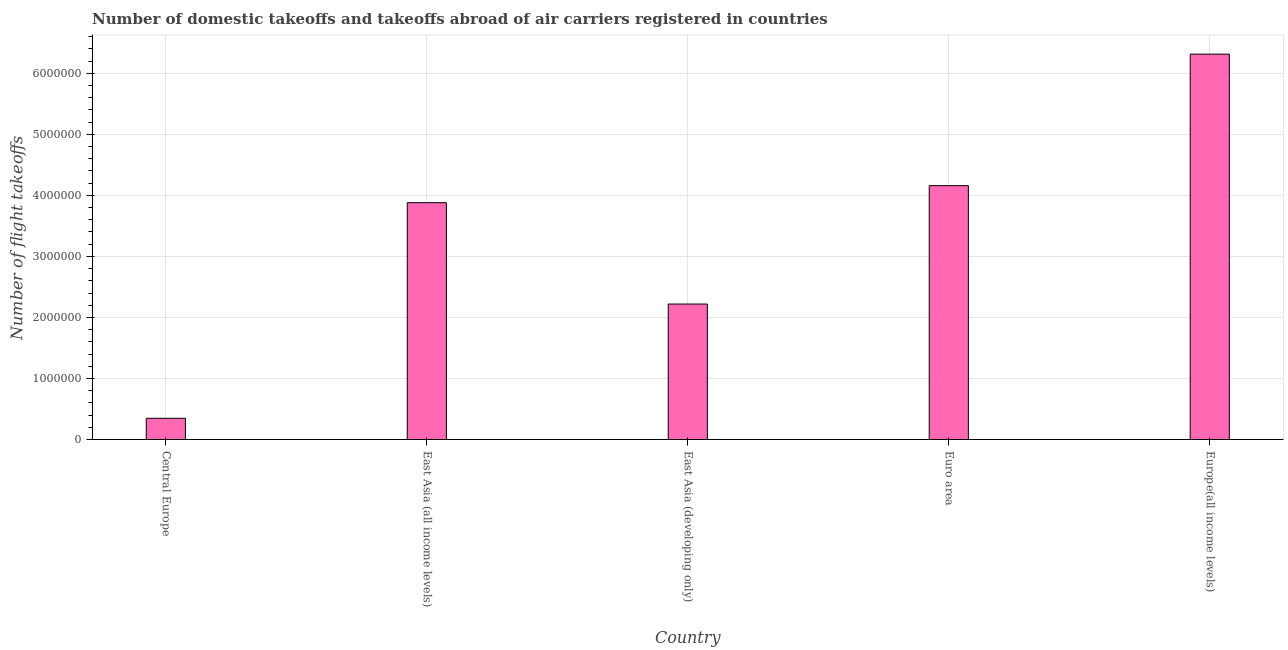Does the graph contain grids?
Provide a succinct answer. Yes. What is the title of the graph?
Keep it short and to the point. Number of domestic takeoffs and takeoffs abroad of air carriers registered in countries. What is the label or title of the X-axis?
Provide a short and direct response. Country. What is the label or title of the Y-axis?
Your answer should be compact. Number of flight takeoffs. What is the number of flight takeoffs in Euro area?
Provide a short and direct response. 4.16e+06. Across all countries, what is the maximum number of flight takeoffs?
Your answer should be compact. 6.31e+06. Across all countries, what is the minimum number of flight takeoffs?
Provide a succinct answer. 3.48e+05. In which country was the number of flight takeoffs maximum?
Your answer should be very brief. Europe(all income levels). In which country was the number of flight takeoffs minimum?
Give a very brief answer. Central Europe. What is the sum of the number of flight takeoffs?
Offer a terse response. 1.69e+07. What is the difference between the number of flight takeoffs in East Asia (developing only) and Euro area?
Provide a succinct answer. -1.94e+06. What is the average number of flight takeoffs per country?
Offer a very short reply. 3.38e+06. What is the median number of flight takeoffs?
Keep it short and to the point. 3.88e+06. What is the ratio of the number of flight takeoffs in East Asia (developing only) to that in Euro area?
Provide a short and direct response. 0.53. Is the number of flight takeoffs in Central Europe less than that in East Asia (all income levels)?
Offer a very short reply. Yes. Is the difference between the number of flight takeoffs in Central Europe and East Asia (developing only) greater than the difference between any two countries?
Keep it short and to the point. No. What is the difference between the highest and the second highest number of flight takeoffs?
Offer a terse response. 2.15e+06. Is the sum of the number of flight takeoffs in Central Europe and Euro area greater than the maximum number of flight takeoffs across all countries?
Provide a short and direct response. No. What is the difference between the highest and the lowest number of flight takeoffs?
Your answer should be very brief. 5.97e+06. How many countries are there in the graph?
Make the answer very short. 5. What is the difference between two consecutive major ticks on the Y-axis?
Provide a succinct answer. 1.00e+06. Are the values on the major ticks of Y-axis written in scientific E-notation?
Make the answer very short. No. What is the Number of flight takeoffs of Central Europe?
Provide a short and direct response. 3.48e+05. What is the Number of flight takeoffs in East Asia (all income levels)?
Your response must be concise. 3.88e+06. What is the Number of flight takeoffs of East Asia (developing only)?
Keep it short and to the point. 2.22e+06. What is the Number of flight takeoffs in Euro area?
Provide a short and direct response. 4.16e+06. What is the Number of flight takeoffs of Europe(all income levels)?
Offer a very short reply. 6.31e+06. What is the difference between the Number of flight takeoffs in Central Europe and East Asia (all income levels)?
Provide a short and direct response. -3.53e+06. What is the difference between the Number of flight takeoffs in Central Europe and East Asia (developing only)?
Offer a very short reply. -1.87e+06. What is the difference between the Number of flight takeoffs in Central Europe and Euro area?
Your answer should be compact. -3.81e+06. What is the difference between the Number of flight takeoffs in Central Europe and Europe(all income levels)?
Keep it short and to the point. -5.97e+06. What is the difference between the Number of flight takeoffs in East Asia (all income levels) and East Asia (developing only)?
Make the answer very short. 1.66e+06. What is the difference between the Number of flight takeoffs in East Asia (all income levels) and Euro area?
Offer a terse response. -2.79e+05. What is the difference between the Number of flight takeoffs in East Asia (all income levels) and Europe(all income levels)?
Offer a terse response. -2.43e+06. What is the difference between the Number of flight takeoffs in East Asia (developing only) and Euro area?
Provide a short and direct response. -1.94e+06. What is the difference between the Number of flight takeoffs in East Asia (developing only) and Europe(all income levels)?
Give a very brief answer. -4.09e+06. What is the difference between the Number of flight takeoffs in Euro area and Europe(all income levels)?
Offer a terse response. -2.15e+06. What is the ratio of the Number of flight takeoffs in Central Europe to that in East Asia (all income levels)?
Make the answer very short. 0.09. What is the ratio of the Number of flight takeoffs in Central Europe to that in East Asia (developing only)?
Your answer should be very brief. 0.16. What is the ratio of the Number of flight takeoffs in Central Europe to that in Euro area?
Your response must be concise. 0.08. What is the ratio of the Number of flight takeoffs in Central Europe to that in Europe(all income levels)?
Keep it short and to the point. 0.06. What is the ratio of the Number of flight takeoffs in East Asia (all income levels) to that in East Asia (developing only)?
Offer a terse response. 1.75. What is the ratio of the Number of flight takeoffs in East Asia (all income levels) to that in Euro area?
Your answer should be very brief. 0.93. What is the ratio of the Number of flight takeoffs in East Asia (all income levels) to that in Europe(all income levels)?
Your answer should be compact. 0.61. What is the ratio of the Number of flight takeoffs in East Asia (developing only) to that in Euro area?
Keep it short and to the point. 0.53. What is the ratio of the Number of flight takeoffs in East Asia (developing only) to that in Europe(all income levels)?
Provide a short and direct response. 0.35. What is the ratio of the Number of flight takeoffs in Euro area to that in Europe(all income levels)?
Ensure brevity in your answer.  0.66. 